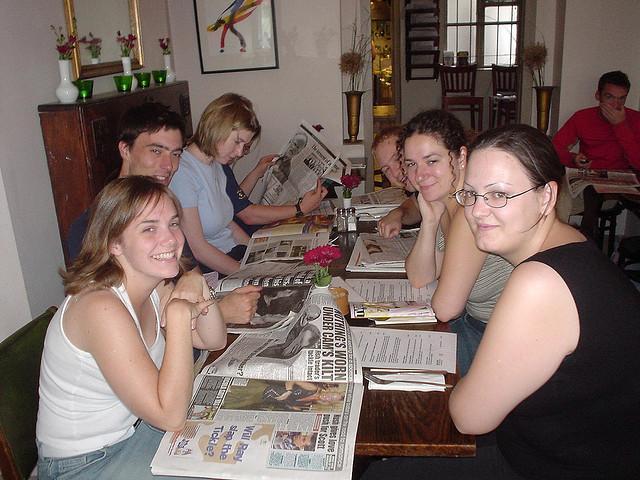How many vases are reflected in the mirror?
Give a very brief answer. 1. How many chairs are visible?
Give a very brief answer. 2. How many people are there?
Give a very brief answer. 8. How many dogs are sitting down?
Give a very brief answer. 0. 